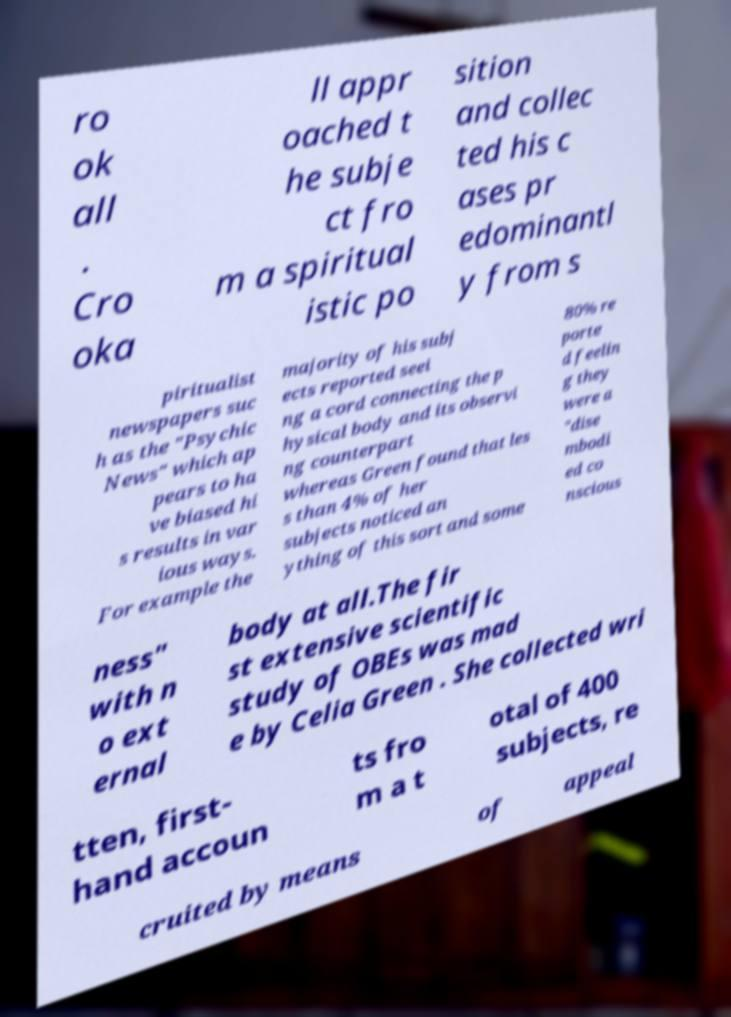There's text embedded in this image that I need extracted. Can you transcribe it verbatim? ro ok all . Cro oka ll appr oached t he subje ct fro m a spiritual istic po sition and collec ted his c ases pr edominantl y from s piritualist newspapers suc h as the "Psychic News" which ap pears to ha ve biased hi s results in var ious ways. For example the majority of his subj ects reported seei ng a cord connecting the p hysical body and its observi ng counterpart whereas Green found that les s than 4% of her subjects noticed an ything of this sort and some 80% re porte d feelin g they were a "dise mbodi ed co nscious ness" with n o ext ernal body at all.The fir st extensive scientific study of OBEs was mad e by Celia Green . She collected wri tten, first- hand accoun ts fro m a t otal of 400 subjects, re cruited by means of appeal 